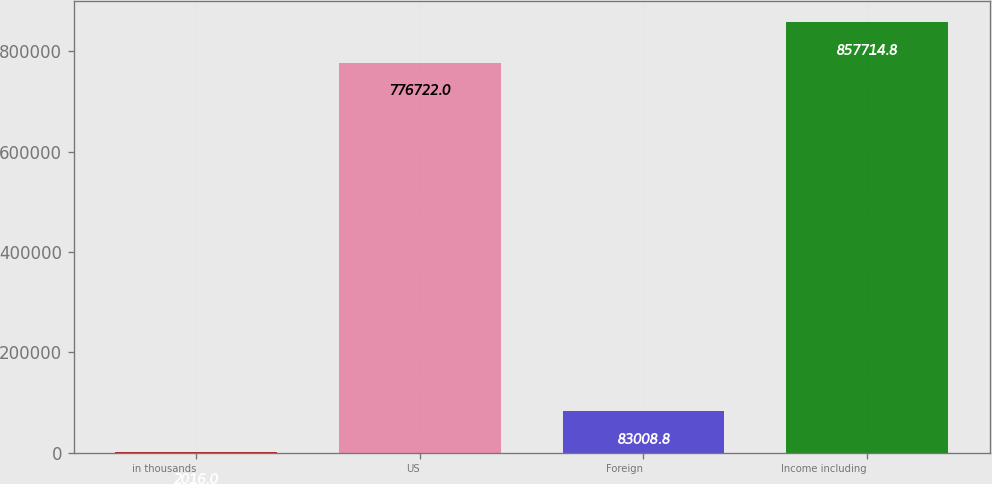Convert chart. <chart><loc_0><loc_0><loc_500><loc_500><bar_chart><fcel>in thousands<fcel>US<fcel>Foreign<fcel>Income including<nl><fcel>2016<fcel>776722<fcel>83008.8<fcel>857715<nl></chart> 